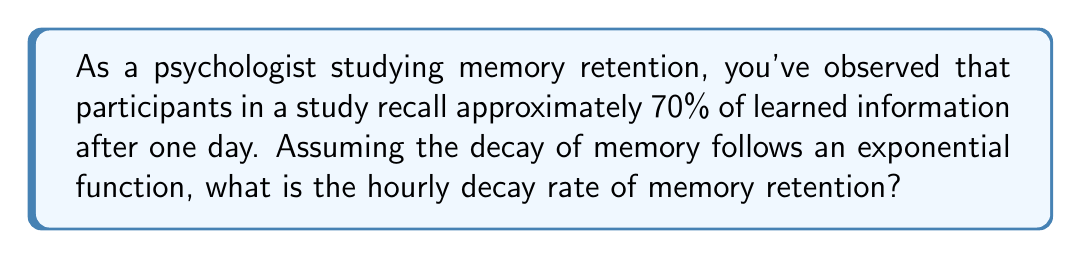Provide a solution to this math problem. Let's approach this step-by-step:

1) The general form of an exponential decay function is:
   $$ A(t) = A_0 \cdot e^{-rt} $$
   Where:
   $A(t)$ is the amount at time $t$
   $A_0$ is the initial amount
   $r$ is the decay rate
   $t$ is the time

2) We know that after 24 hours (1 day), 70% of the information is retained. Let's set up the equation:
   $$ 0.70 = 1 \cdot e^{-r \cdot 24} $$

3) Take the natural logarithm of both sides:
   $$ \ln(0.70) = \ln(e^{-r \cdot 24}) $$

4) Simplify the right side using logarithm properties:
   $$ \ln(0.70) = -24r $$

5) Solve for $r$:
   $$ r = -\frac{\ln(0.70)}{24} $$

6) Calculate the value:
   $$ r \approx 0.0149 $$

This represents the hourly decay rate.
Answer: $0.0149$ per hour 